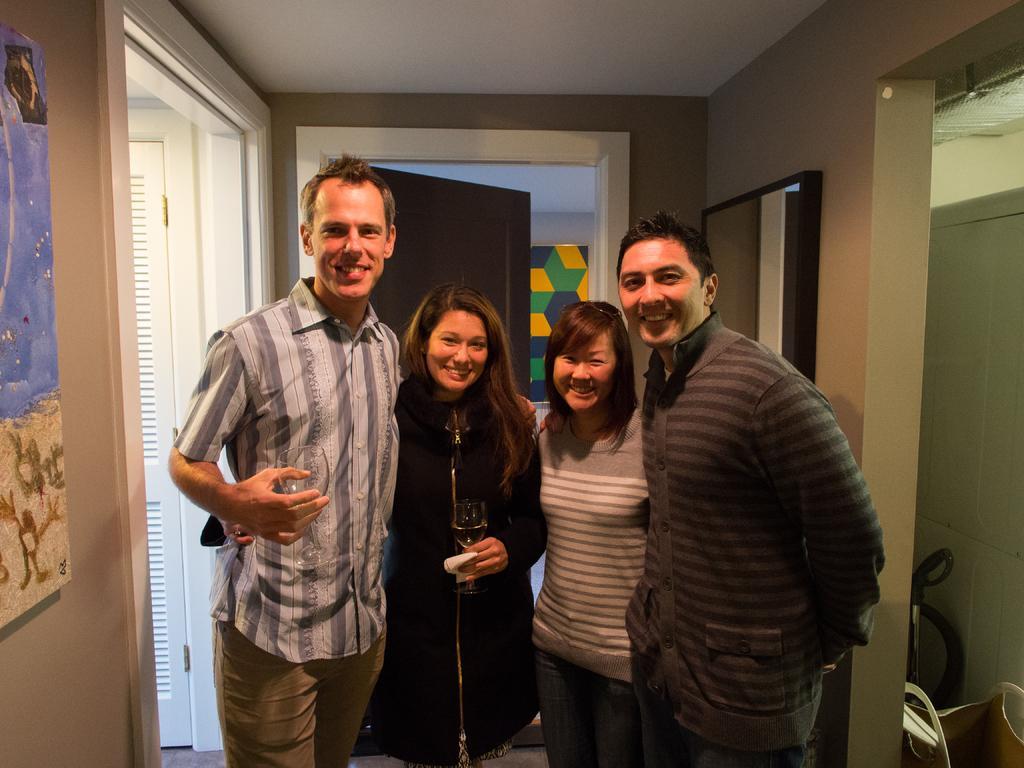Could you give a brief overview of what you see in this image? In this image I can see few people are wearing different color dresses. Back I can see few doors and few boards attached to the wall. Few person are holding glasses. 